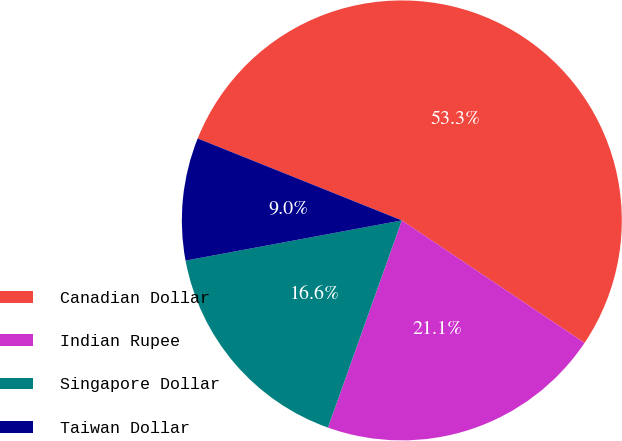Convert chart to OTSL. <chart><loc_0><loc_0><loc_500><loc_500><pie_chart><fcel>Canadian Dollar<fcel>Indian Rupee<fcel>Singapore Dollar<fcel>Taiwan Dollar<nl><fcel>53.32%<fcel>21.05%<fcel>16.62%<fcel>9.0%<nl></chart> 